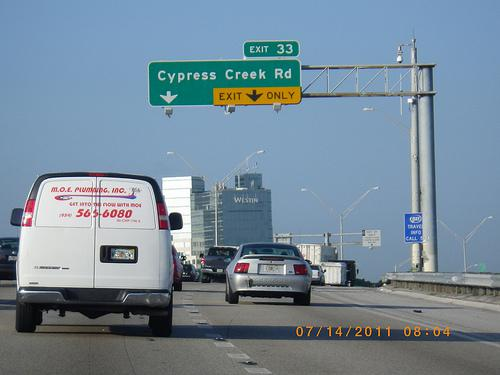Question: how many vans are in the picture?
Choices:
A. Twelve.
B. Three.
C. One.
D. Five.
Answer with the letter. Answer: C Question: what is the above the vehicles?
Choices:
A. A bridge.
B. An overpass.
C. A roof.
D. Sign.
Answer with the letter. Answer: D Question: where was the picture taken?
Choices:
A. In a backyard.
B. Highway.
C. In a park.
D. At a tennis court.
Answer with the letter. Answer: B Question: what is on the highway?
Choices:
A. Vehicles.
B. A truck.
C. A car.
D. A bus.
Answer with the letter. Answer: A Question: who are driving the vehicles?
Choices:
A. A man.
B. People.
C. A busdriver.
D. A cabie.
Answer with the letter. Answer: B Question: what color is the van in the picture?
Choices:
A. Green.
B. Gray.
C. White.
D. Blue.
Answer with the letter. Answer: C 